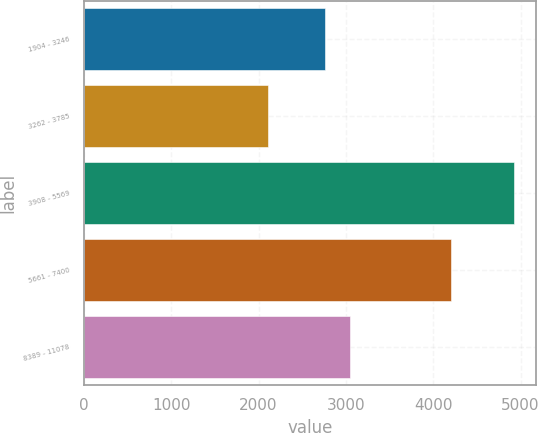Convert chart to OTSL. <chart><loc_0><loc_0><loc_500><loc_500><bar_chart><fcel>1904 - 3246<fcel>3262 - 3785<fcel>3908 - 5569<fcel>5661 - 7400<fcel>8389 - 11078<nl><fcel>2764<fcel>2109<fcel>4929<fcel>4199<fcel>3046<nl></chart> 